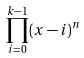Convert formula to latex. <formula><loc_0><loc_0><loc_500><loc_500>\prod _ { i = 0 } ^ { k - 1 } ( x - i ) ^ { n }</formula> 